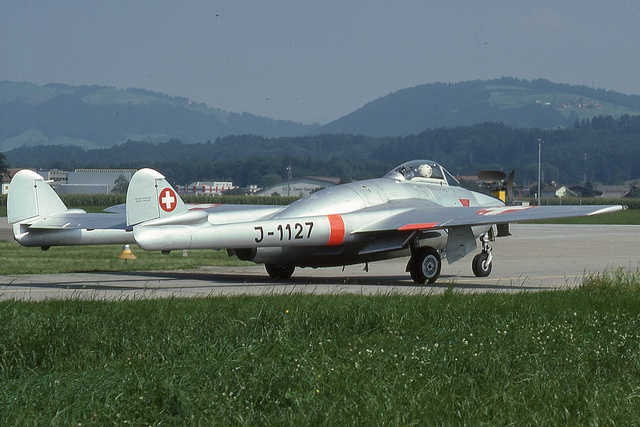Describe the objects in this image and their specific colors. I can see airplane in gray, lightgray, black, and darkgray tones and airplane in gray, lightgray, and darkgray tones in this image. 